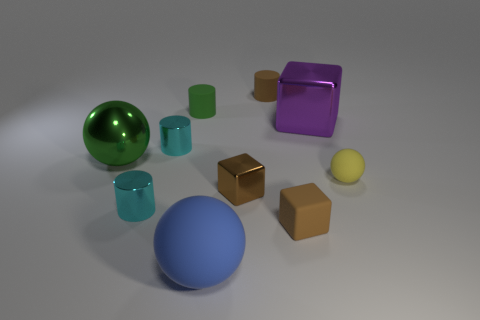Subtract all brown blocks. How many blocks are left? 1 Subtract all blocks. How many objects are left? 7 Subtract 2 cylinders. How many cylinders are left? 2 Add 6 tiny yellow shiny cylinders. How many tiny yellow shiny cylinders exist? 6 Subtract all yellow spheres. How many spheres are left? 2 Subtract 0 gray balls. How many objects are left? 10 Subtract all brown blocks. Subtract all yellow balls. How many blocks are left? 1 Subtract all gray balls. How many brown cubes are left? 2 Subtract all tiny cyan cylinders. Subtract all green balls. How many objects are left? 7 Add 9 large rubber spheres. How many large rubber spheres are left? 10 